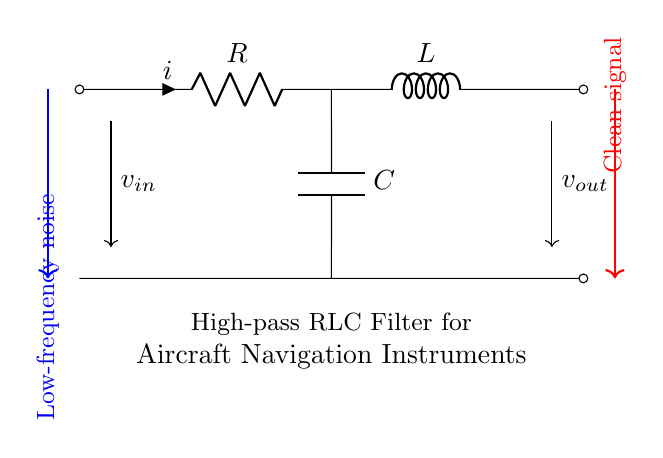What type of filter is represented by this circuit? This circuit is a high-pass RLC filter; it allows high-frequency signals to pass while attenuating low-frequency signals, explained by the arrangement of the resistor, inductor, and capacitor.
Answer: High-pass RLC filter What are the components used in this filter? The components in this circuit include a resistor, an inductor, and a capacitor, which are crucial for the functioning of a high-pass filter regarding frequency selection.
Answer: Resistor, inductor, capacitor What is the role of the capacitor in this circuit? The capacitor blocks low-frequency signals while allowing high-frequency signals to pass, which is essential for reducing low-frequency noise present in aircraft navigation instruments.
Answer: Blocks low-frequency signals What is the direction of the input current? The input current flows from the input voltage source through the resistor, to the inductor, and finally towards the output, indicating the path of current flow that leads to filtering out noise.
Answer: From left to right What type of signals does this filter aim to eliminate? This filter aims to eliminate low-frequency noise that could interfere with the accuracy of aircraft navigation instruments, indicating its purpose for operational safety and performance.
Answer: Low-frequency noise What happens to high-frequency signals in this circuit? High-frequency signals are allowed to pass through the circuit with minimal attenuation, ensuring that essential signals remain intact for processing and display in the navigation instruments.
Answer: Pass through with minimal attenuation 